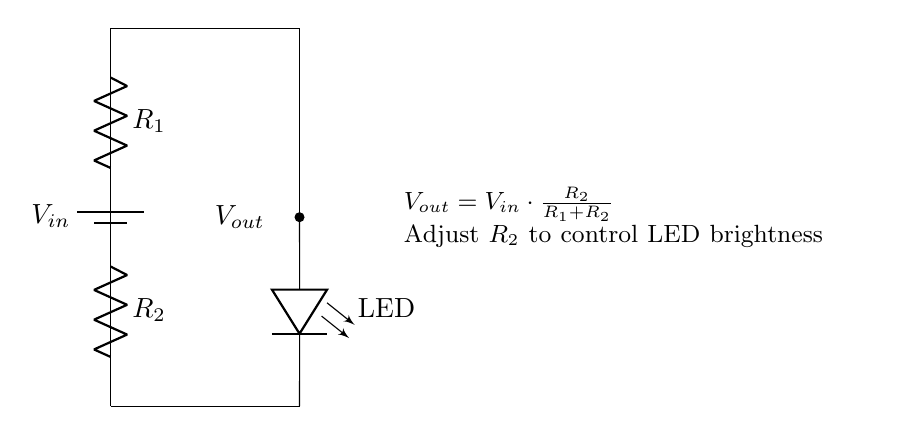What is the input voltage labeled in the circuit? The input voltage is labeled as Vin, which is placed at the top of the circuit connected to the battery symbol.
Answer: Vin What components are used in this circuit? The circuit includes a battery, two resistors (R1 and R2), and an LED. Each component is clearly identified in the diagram with appropriate labels.
Answer: Battery, R1, R2, LED What is the purpose of resistor R2 in the circuit? Resistor R2 is used to set the output voltage (Vout) which in turn controls the brightness of the LED. Its value can be adjusted to change the current flowing through the LED.
Answer: Control brightness How is the output voltage (Vout) defined in relation to Vin? The output voltage is defined mathematically as Vout = Vin multiplied by the ratio of R2 to the sum of R1 and R2. This expression shows how Vout is influenced by the resistor values relative to the input voltage.
Answer: Vout = Vin * (R2 / (R1 + R2)) What happens to the LED brightness if R2 increases? If R2 increases while R1 remains the same, the output voltage Vout increases, leading to a higher current through the LED, which results in increased brightness. This follows from the voltage divider principle.
Answer: Increases brightness What role does R1 play in the voltage divider? Resistor R1 contributes to setting the total resistance in the circuit, which affects the division of voltage and determines how much voltage is reduced for Vout as compared to Vin. Hence, it also impacts the LED brightness indirectly.
Answer: Sets total resistance What happens if R1 is decreased while keeping R2 constant? Decreasing R1 will cause the output voltage Vout to increase since the fraction of Vout relative to Vin will shift, allowing more voltage to reach the LED, thereby increasing its brightness.
Answer: Vout increases 